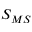<formula> <loc_0><loc_0><loc_500><loc_500>S _ { M S }</formula> 